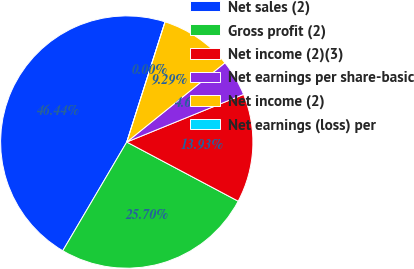Convert chart. <chart><loc_0><loc_0><loc_500><loc_500><pie_chart><fcel>Net sales (2)<fcel>Gross profit (2)<fcel>Net income (2)(3)<fcel>Net earnings per share-basic<fcel>Net income (2)<fcel>Net earnings (loss) per<nl><fcel>46.44%<fcel>25.7%<fcel>13.93%<fcel>4.64%<fcel>9.29%<fcel>0.0%<nl></chart> 